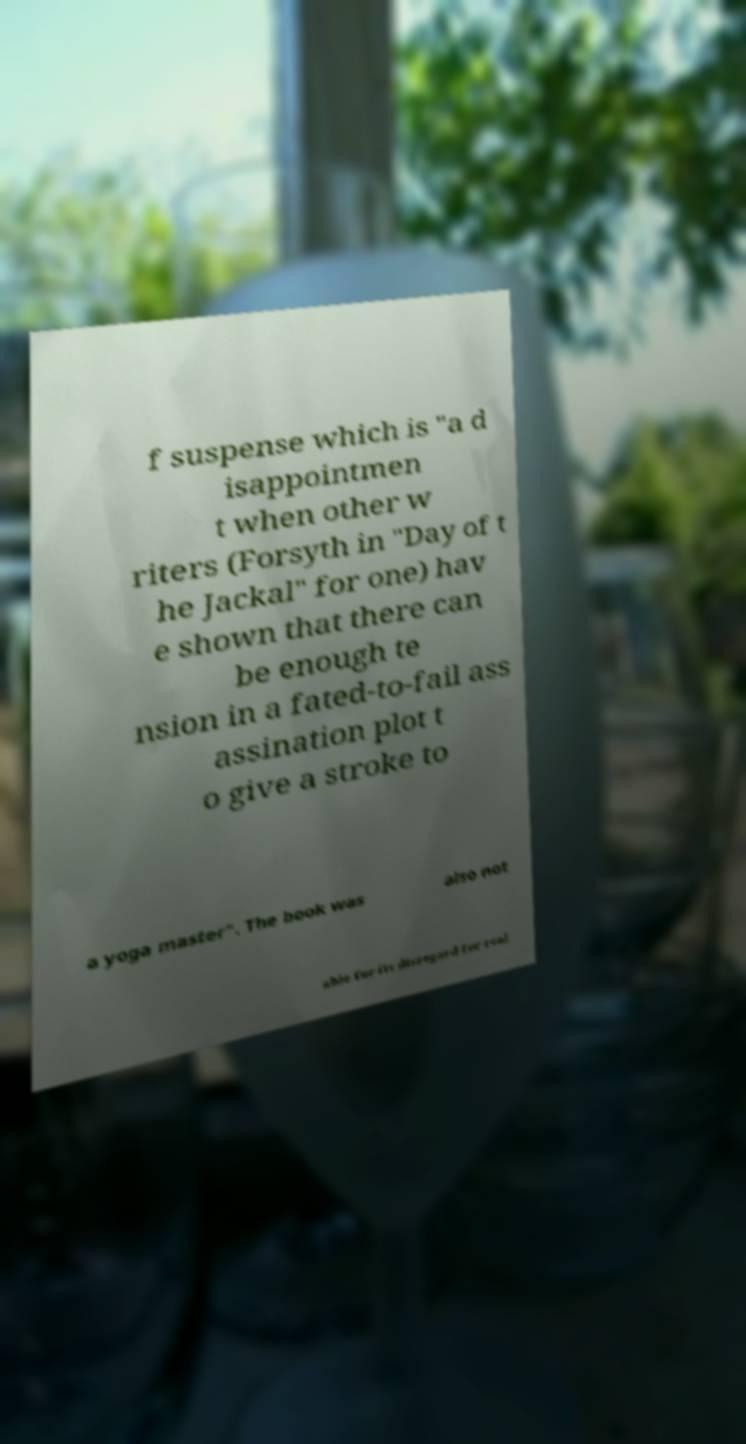Could you extract and type out the text from this image? f suspense which is "a d isappointmen t when other w riters (Forsyth in "Day of t he Jackal" for one) hav e shown that there can be enough te nsion in a fated-to-fail ass assination plot t o give a stroke to a yoga master". The book was also not able for its disregard for real 